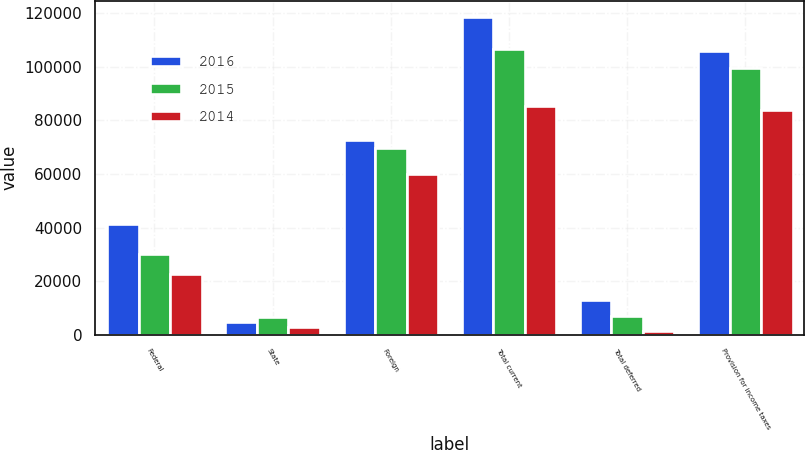<chart> <loc_0><loc_0><loc_500><loc_500><stacked_bar_chart><ecel><fcel>Federal<fcel>State<fcel>Foreign<fcel>Total current<fcel>Total deferred<fcel>Provision for income taxes<nl><fcel>2016<fcel>41407<fcel>4750<fcel>72600<fcel>118757<fcel>12908<fcel>105849<nl><fcel>2015<fcel>30334<fcel>6616<fcel>69793<fcel>106743<fcel>7153<fcel>99590<nl><fcel>2014<fcel>22549<fcel>2823<fcel>60143<fcel>85515<fcel>1486<fcel>84029<nl></chart> 